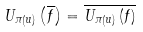Convert formula to latex. <formula><loc_0><loc_0><loc_500><loc_500>U _ { \pi \left ( u \right ) } \left ( \overline { f } \right ) = \overline { U _ { \pi \left ( u \right ) } \left ( f \right ) }</formula> 